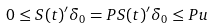<formula> <loc_0><loc_0><loc_500><loc_500>0 \leq S ( t ) ^ { \prime } \delta _ { 0 } = P S ( t ) ^ { \prime } \delta _ { 0 } \leq P u</formula> 